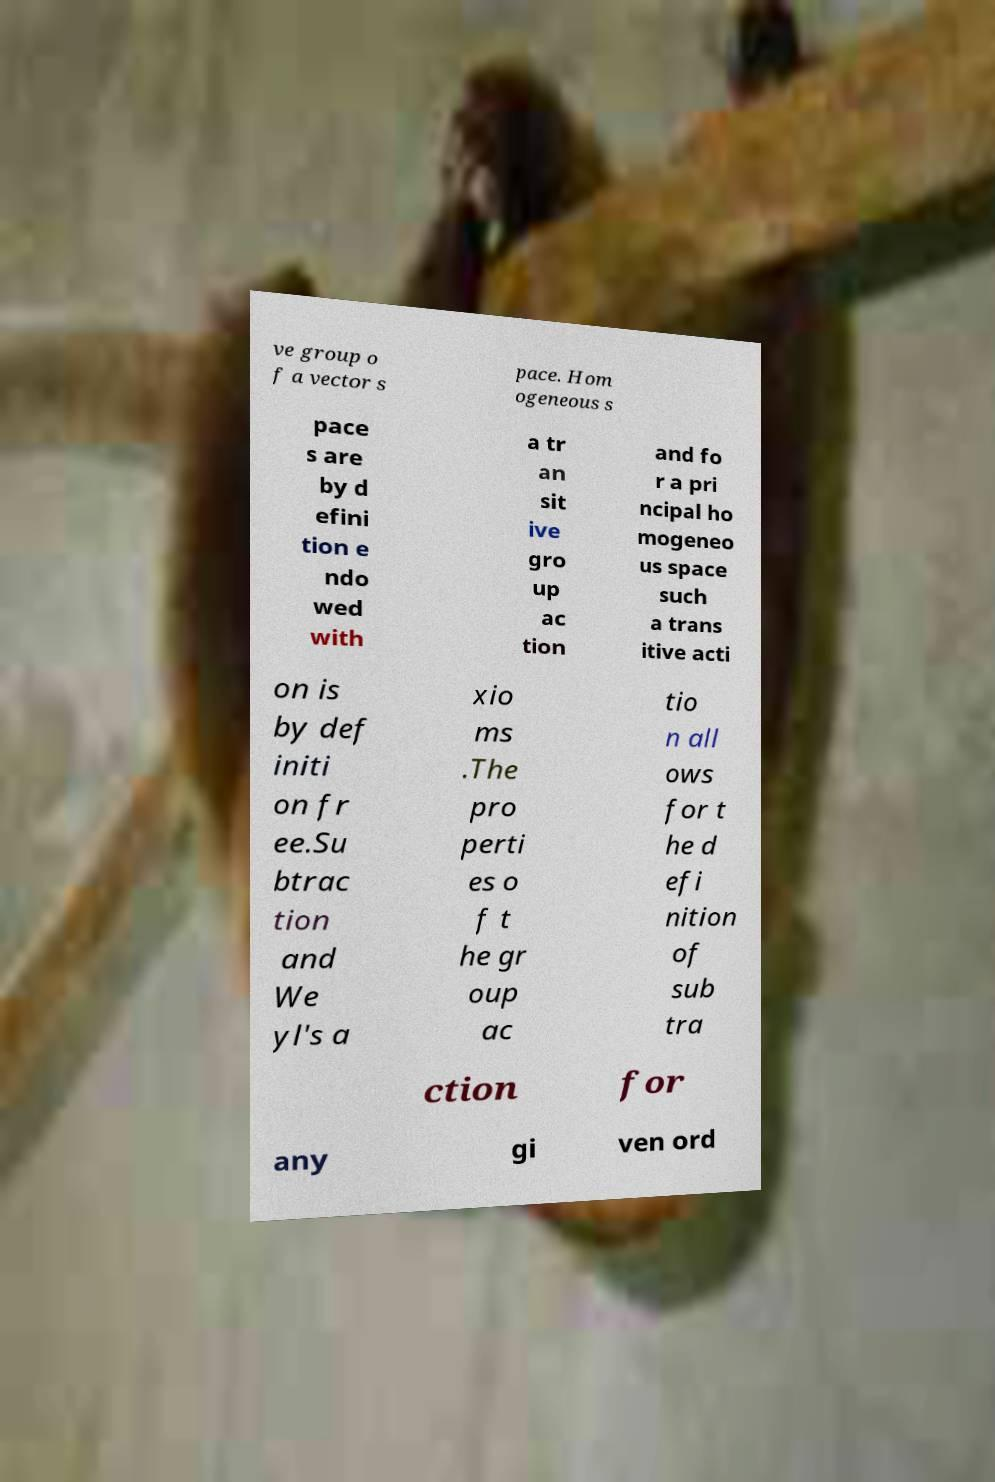Could you assist in decoding the text presented in this image and type it out clearly? ve group o f a vector s pace. Hom ogeneous s pace s are by d efini tion e ndo wed with a tr an sit ive gro up ac tion and fo r a pri ncipal ho mogeneo us space such a trans itive acti on is by def initi on fr ee.Su btrac tion and We yl's a xio ms .The pro perti es o f t he gr oup ac tio n all ows for t he d efi nition of sub tra ction for any gi ven ord 